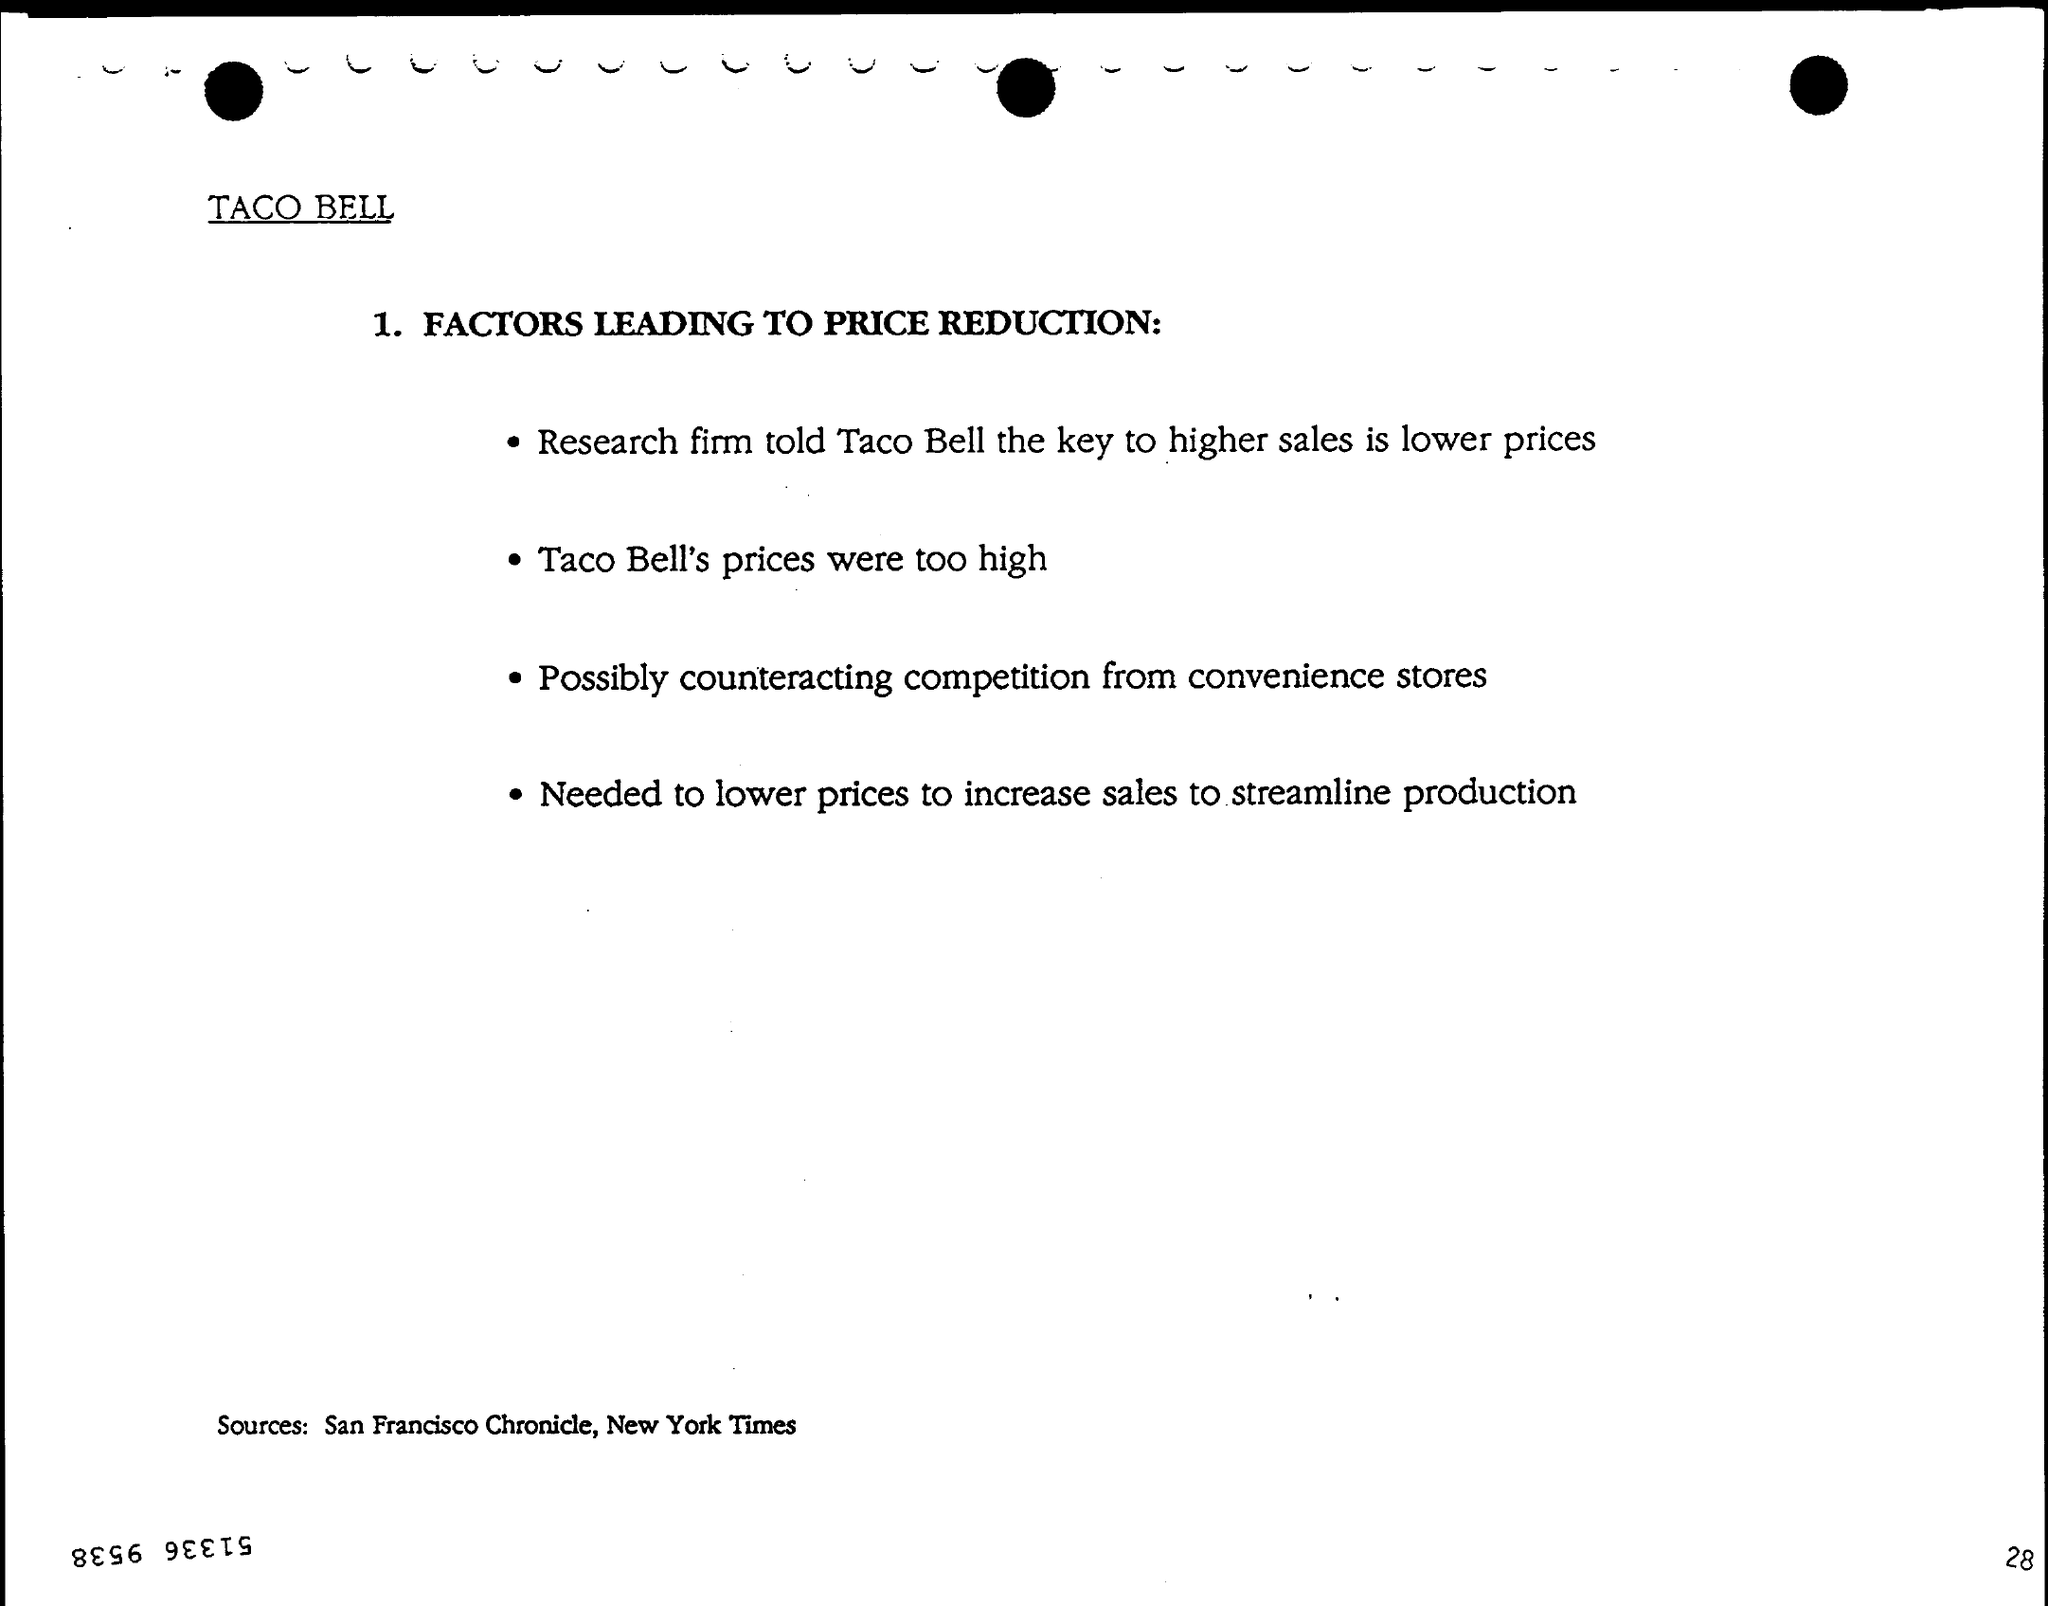Which brand is mentioned?
Make the answer very short. TACO BELL. What is the key to higher sales according to Research firm?
Provide a short and direct response. Lower prices. What are the sources?
Provide a short and direct response. San Francisco Chronicle, New York Times. 